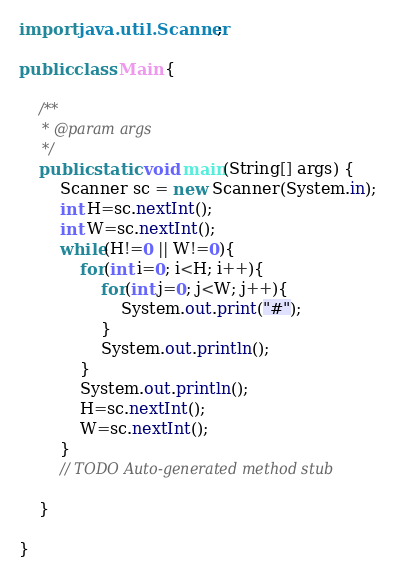<code> <loc_0><loc_0><loc_500><loc_500><_Java_>import java.util.Scanner;

public class Main {

	/**
	 * @param args
	 */
	public static void main(String[] args) {
		Scanner sc = new Scanner(System.in);
		int H=sc.nextInt();
		int W=sc.nextInt();
		while(H!=0 || W!=0){
			for(int i=0; i<H; i++){
				for(int j=0; j<W; j++){
					System.out.print("#");
				}
				System.out.println();
			}
			System.out.println();
			H=sc.nextInt();
			W=sc.nextInt();
		}
		// TODO Auto-generated method stub

	}

}</code> 